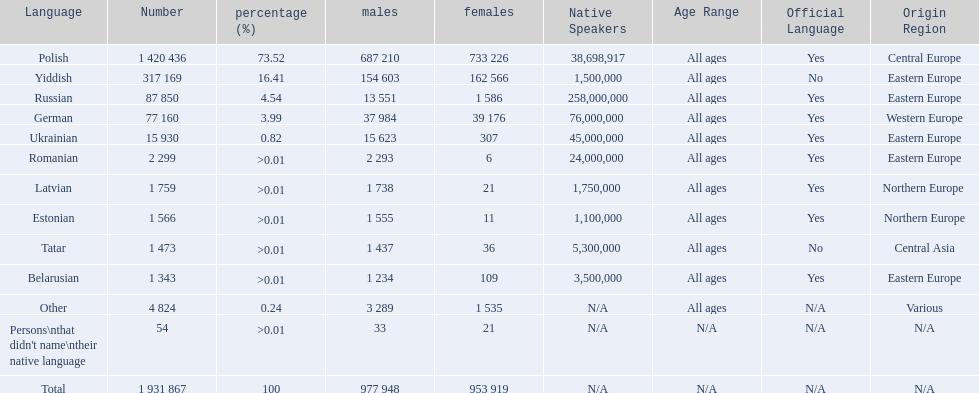Which languages are spoken by more than 50,000 people? Polish, Yiddish, Russian, German. Of these languages, which ones are spoken by less than 15% of the population? Russian, German. Of the remaining two, which one is spoken by 37,984 males? German. 